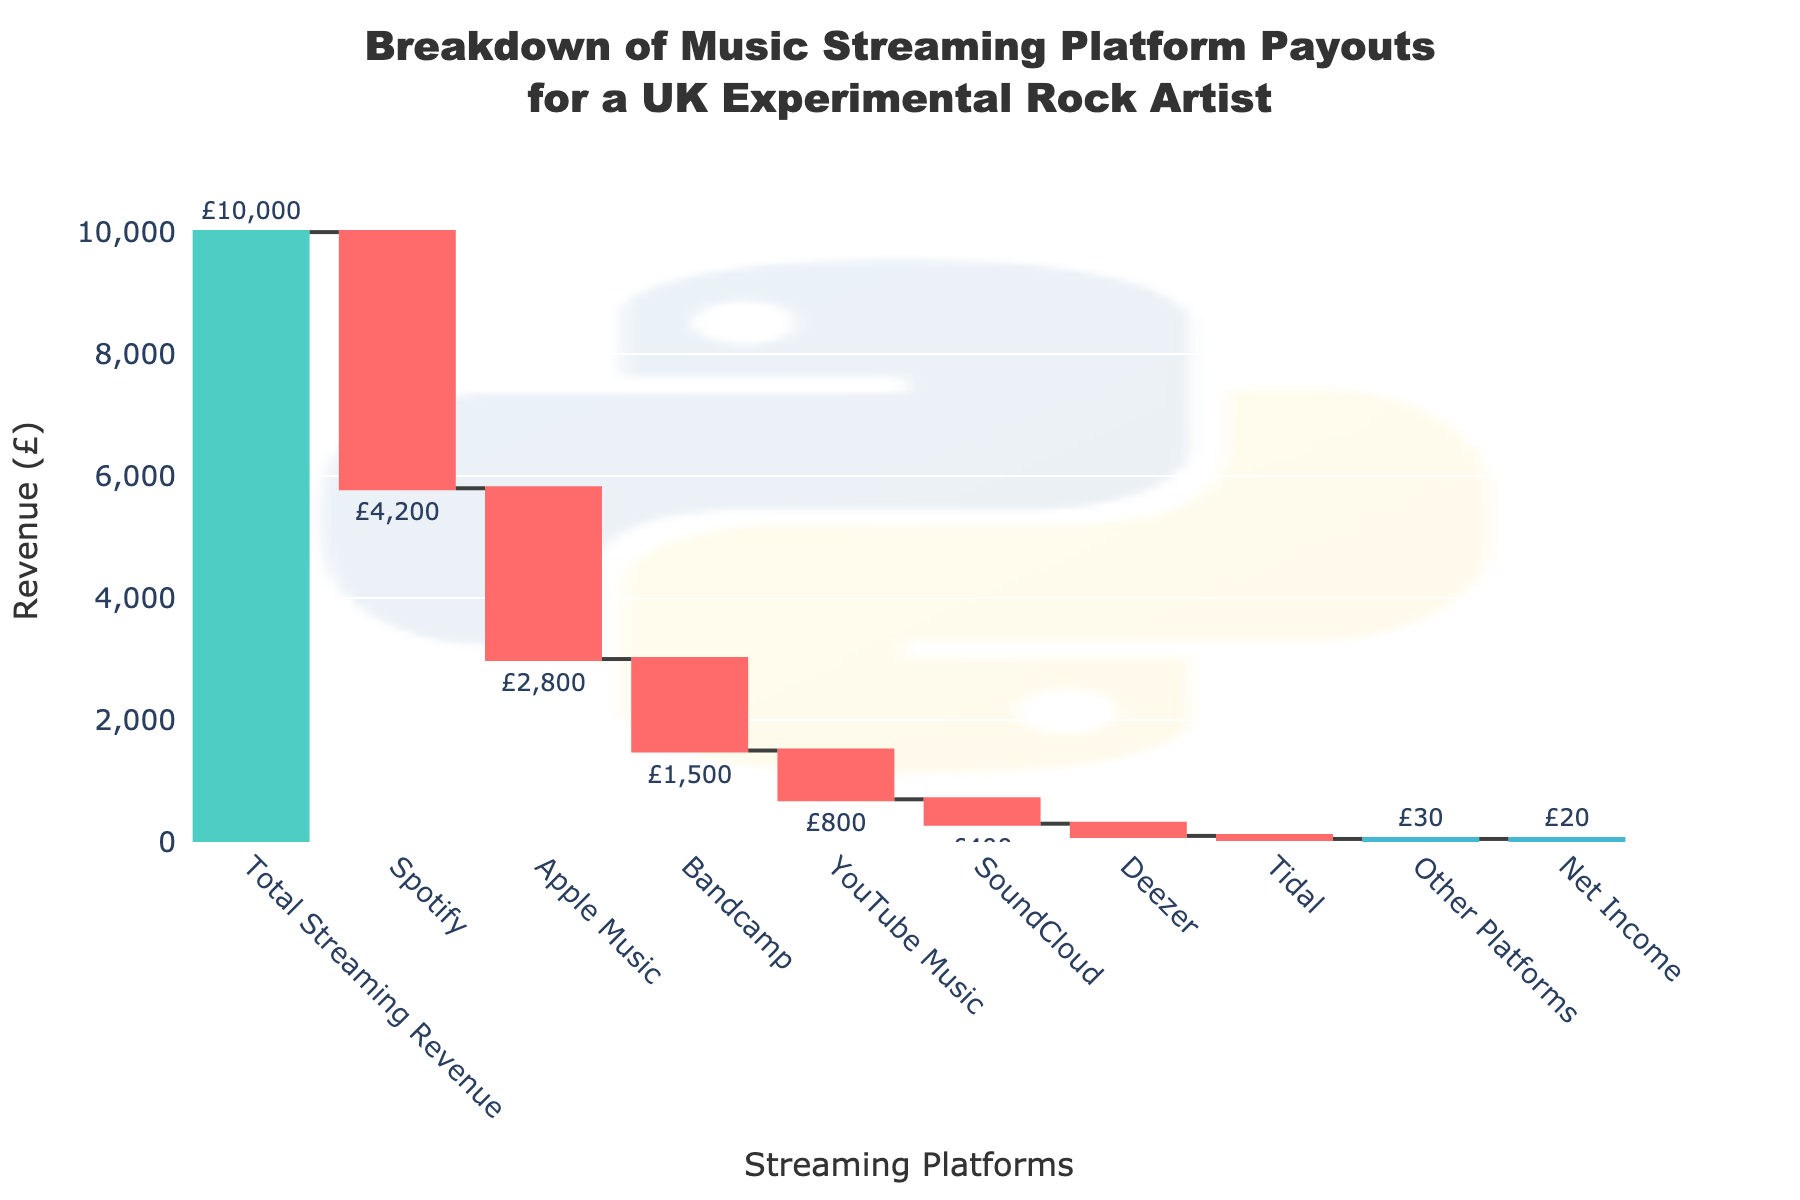What is the total streaming revenue before deductions? The figure shows the total streaming revenue as the first bar in the chart labeled "Total Streaming Revenue" with a value of £10,000.
Answer: £10,000 Which platform contributes the highest deduction? The highest deduction can be seen by identifying the bar with the largest negative value. Here, it is Spotify with a deduction of £4,200.
Answer: Spotify What is the total revenue deducted by Apple Music and YouTube Music combined? To find the combined deduction by Apple Music and YouTube Music, we sum up their values: £2,800 (Apple Music) + £800 (YouTube Music) = £3,600.
Answer: £3,600 How does the deduction by Bandcamp compare to that by SoundCloud? Compare the negative values of Bandcamp and SoundCloud. Bandcamp deducts £1,500, while SoundCloud deducts £400. Bandcamp's deduction is larger.
Answer: Bandcamp’s deduction is larger What is the net income after all deductions? The net income after all deductions is represented by the last bar labeled "Net Income" with a value of £20.
Answer: £20 How much less is the deduction by Deezer compared to that by Apple Music? Subtract the Deezer deduction (£200) from the Apple Music deduction (£2,800). £2,800 - £200 = £2,600.
Answer: £2,600 less What percentage of the total streaming revenue is deducted by Spotify? Calculate the percentage by dividing the Spotify deduction by the total revenue and multiplying by 100: (£4,200 / £10,000) * 100 = 42%.
Answer: 42% What is the combined deduction by platforms other than Spotify and Apple Music? Add the deductions from Bandcamp, YouTube Music, SoundCloud, Deezer, Tidal, and Other Platforms: £1,500 + £800 + £400 + £200 + £50 + £30 = £2,980.
Answer: £2,980 Which platform has the smallest deduction, and how much is it? Identify the smallest negative value in the chart, which is Tidal with a deduction of £50.
Answer: Tidal, £50 If the revenue from Spotify were 10% higher, what would be its new deduction? Calculate 10% of the current Spotify deduction and add it to the original amount: 10% of £4,200 is £420. Thus, £4,200 + £420 = £4,620.
Answer: £4,620 